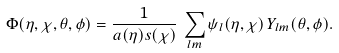Convert formula to latex. <formula><loc_0><loc_0><loc_500><loc_500>\Phi ( \eta , \chi , \theta , \phi ) = \frac { 1 } { a ( \eta ) s ( \chi ) } \, \sum _ { l m } \psi _ { l } ( \eta , \chi ) \, Y _ { l m } ( \theta , \phi ) .</formula> 